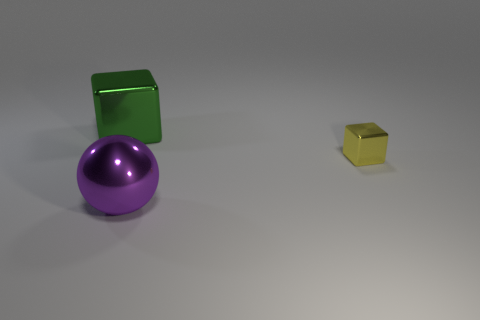There is a large green object that is the same shape as the yellow thing; what material is it?
Provide a short and direct response. Metal. How many metal objects are in front of the large thing that is right of the metallic cube left of the small cube?
Ensure brevity in your answer.  0. Are there any other things that are the same color as the sphere?
Provide a succinct answer. No. How many metal cubes are on the right side of the sphere and left of the purple shiny thing?
Keep it short and to the point. 0. Is the size of the metallic thing that is on the left side of the large sphere the same as the object in front of the small shiny thing?
Make the answer very short. Yes. What number of things are yellow cubes on the right side of the metal sphere or large objects?
Ensure brevity in your answer.  3. Do the green metal block and the shiny block right of the purple sphere have the same size?
Provide a succinct answer. No. What number of objects are either yellow shiny objects to the right of the large green metal block or metallic objects that are to the left of the tiny yellow shiny thing?
Provide a short and direct response. 3. There is a big metal object that is in front of the green cube; what color is it?
Your answer should be very brief. Purple. There is a big metallic object that is in front of the small object; is there a big shiny sphere to the left of it?
Provide a succinct answer. No. 